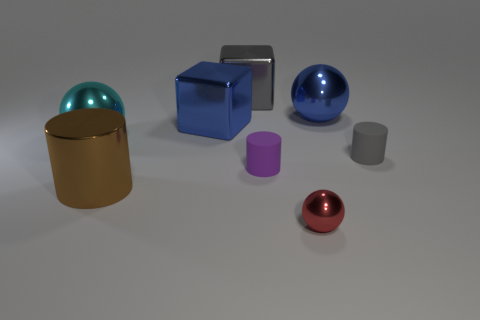Subtract all large balls. How many balls are left? 1 Subtract 1 cylinders. How many cylinders are left? 2 Add 1 large cyan rubber cylinders. How many objects exist? 9 Subtract all cubes. How many objects are left? 6 Subtract all gray spheres. Subtract all blue cylinders. How many spheres are left? 3 Add 8 tiny purple objects. How many tiny purple objects are left? 9 Add 3 matte cylinders. How many matte cylinders exist? 5 Subtract 1 blue spheres. How many objects are left? 7 Subtract all tiny gray matte cylinders. Subtract all blue objects. How many objects are left? 5 